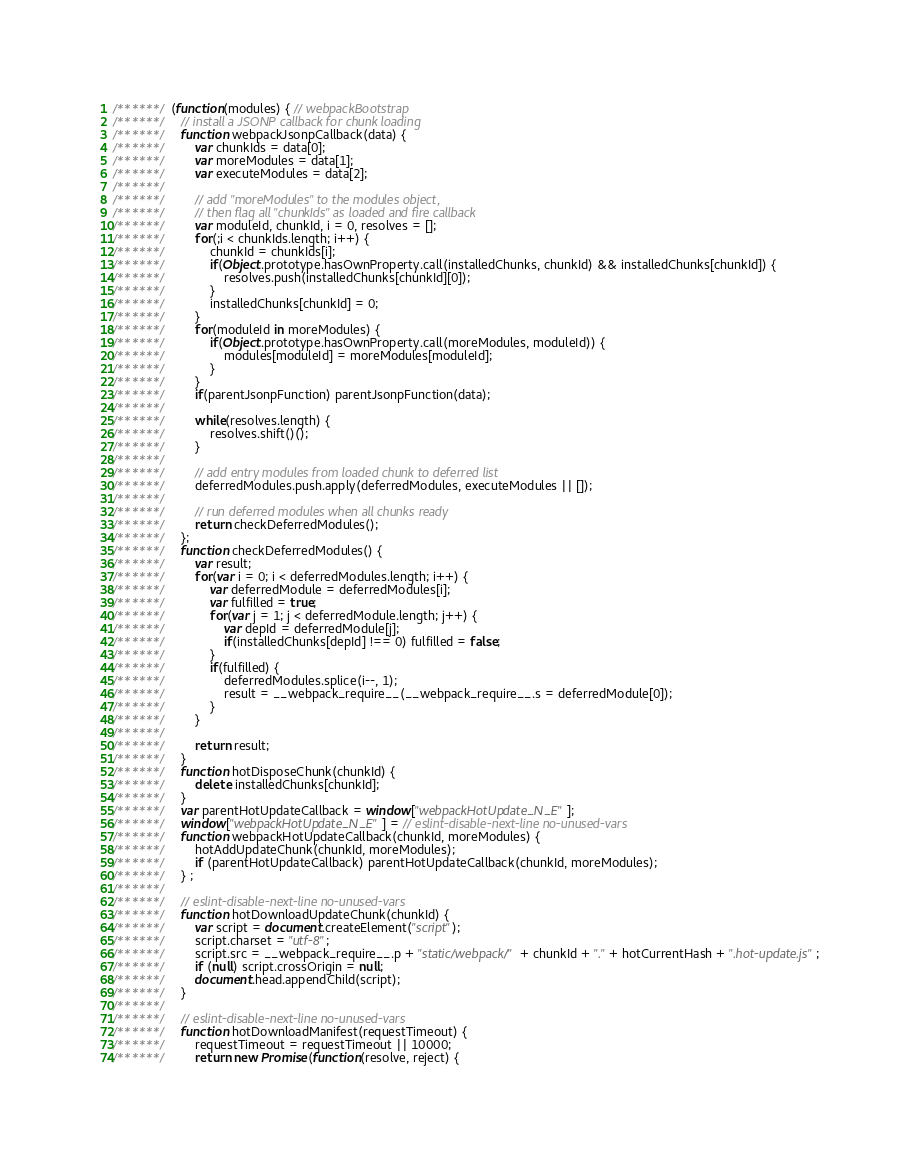Convert code to text. <code><loc_0><loc_0><loc_500><loc_500><_JavaScript_>/******/ (function(modules) { // webpackBootstrap
/******/ 	// install a JSONP callback for chunk loading
/******/ 	function webpackJsonpCallback(data) {
/******/ 		var chunkIds = data[0];
/******/ 		var moreModules = data[1];
/******/ 		var executeModules = data[2];
/******/
/******/ 		// add "moreModules" to the modules object,
/******/ 		// then flag all "chunkIds" as loaded and fire callback
/******/ 		var moduleId, chunkId, i = 0, resolves = [];
/******/ 		for(;i < chunkIds.length; i++) {
/******/ 			chunkId = chunkIds[i];
/******/ 			if(Object.prototype.hasOwnProperty.call(installedChunks, chunkId) && installedChunks[chunkId]) {
/******/ 				resolves.push(installedChunks[chunkId][0]);
/******/ 			}
/******/ 			installedChunks[chunkId] = 0;
/******/ 		}
/******/ 		for(moduleId in moreModules) {
/******/ 			if(Object.prototype.hasOwnProperty.call(moreModules, moduleId)) {
/******/ 				modules[moduleId] = moreModules[moduleId];
/******/ 			}
/******/ 		}
/******/ 		if(parentJsonpFunction) parentJsonpFunction(data);
/******/
/******/ 		while(resolves.length) {
/******/ 			resolves.shift()();
/******/ 		}
/******/
/******/ 		// add entry modules from loaded chunk to deferred list
/******/ 		deferredModules.push.apply(deferredModules, executeModules || []);
/******/
/******/ 		// run deferred modules when all chunks ready
/******/ 		return checkDeferredModules();
/******/ 	};
/******/ 	function checkDeferredModules() {
/******/ 		var result;
/******/ 		for(var i = 0; i < deferredModules.length; i++) {
/******/ 			var deferredModule = deferredModules[i];
/******/ 			var fulfilled = true;
/******/ 			for(var j = 1; j < deferredModule.length; j++) {
/******/ 				var depId = deferredModule[j];
/******/ 				if(installedChunks[depId] !== 0) fulfilled = false;
/******/ 			}
/******/ 			if(fulfilled) {
/******/ 				deferredModules.splice(i--, 1);
/******/ 				result = __webpack_require__(__webpack_require__.s = deferredModule[0]);
/******/ 			}
/******/ 		}
/******/
/******/ 		return result;
/******/ 	}
/******/ 	function hotDisposeChunk(chunkId) {
/******/ 		delete installedChunks[chunkId];
/******/ 	}
/******/ 	var parentHotUpdateCallback = window["webpackHotUpdate_N_E"];
/******/ 	window["webpackHotUpdate_N_E"] = // eslint-disable-next-line no-unused-vars
/******/ 	function webpackHotUpdateCallback(chunkId, moreModules) {
/******/ 		hotAddUpdateChunk(chunkId, moreModules);
/******/ 		if (parentHotUpdateCallback) parentHotUpdateCallback(chunkId, moreModules);
/******/ 	} ;
/******/
/******/ 	// eslint-disable-next-line no-unused-vars
/******/ 	function hotDownloadUpdateChunk(chunkId) {
/******/ 		var script = document.createElement("script");
/******/ 		script.charset = "utf-8";
/******/ 		script.src = __webpack_require__.p + "static/webpack/" + chunkId + "." + hotCurrentHash + ".hot-update.js";
/******/ 		if (null) script.crossOrigin = null;
/******/ 		document.head.appendChild(script);
/******/ 	}
/******/
/******/ 	// eslint-disable-next-line no-unused-vars
/******/ 	function hotDownloadManifest(requestTimeout) {
/******/ 		requestTimeout = requestTimeout || 10000;
/******/ 		return new Promise(function(resolve, reject) {</code> 